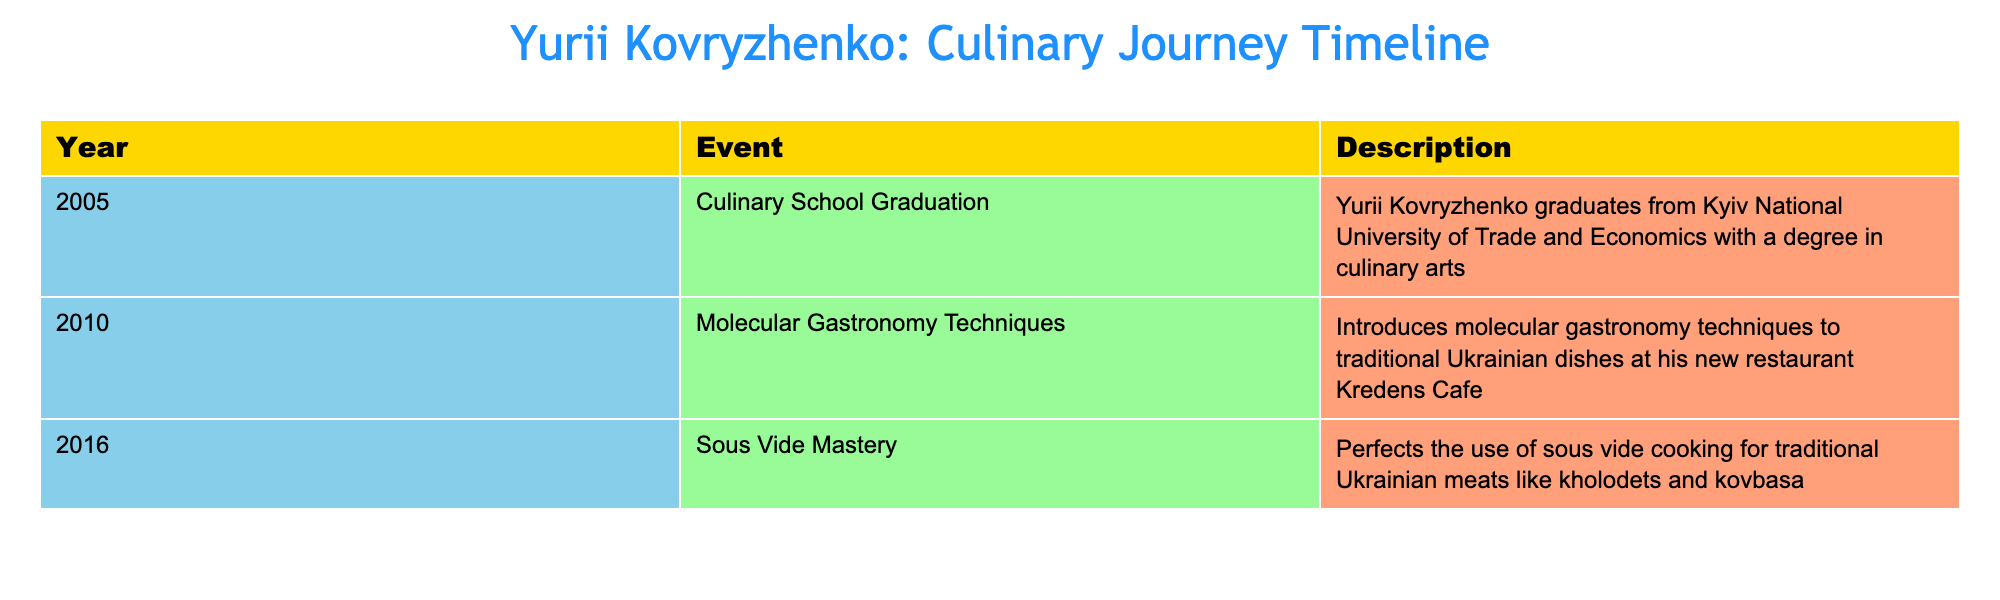What year did Yurii Kovryzhenko graduate from culinary school? The table clearly states that he graduated in 2005, as indicated in the 'Year' column associated with the event 'Culinary School Graduation'.
Answer: 2005 What is one cooking technique that Yurii Kovryzhenko introduced in 2010? The table lists the event 'Molecular Gastronomy Techniques' in the year 2010, clearly indicating that this was the technique he introduced that year.
Answer: Molecular gastronomy techniques How many years passed between Kovryzhenko's culinary school graduation and the introduction of molecular gastronomy techniques? To find the time difference, subtract the graduation year (2005) from the year of introducing molecular gastronomy (2010): 2010 - 2005 = 5 years.
Answer: 5 years Did Yurii Kovryzhenko perfect sous vide cooking before he introduced molecular gastronomy techniques? The table indicates that he introduced molecular gastronomy techniques in 2010 and perfected sous vide cooking in 2016. This shows that he did not perfect sous vide cooking before 2010.
Answer: No Which cooking technique was applied to traditional Ukrainian meats? The table specifies that he perfected 'sous vide cooking' for traditional Ukrainian meats, specifically mentioning kholodets and kovbasa in the description for the 2016 event.
Answer: Sous vide cooking 